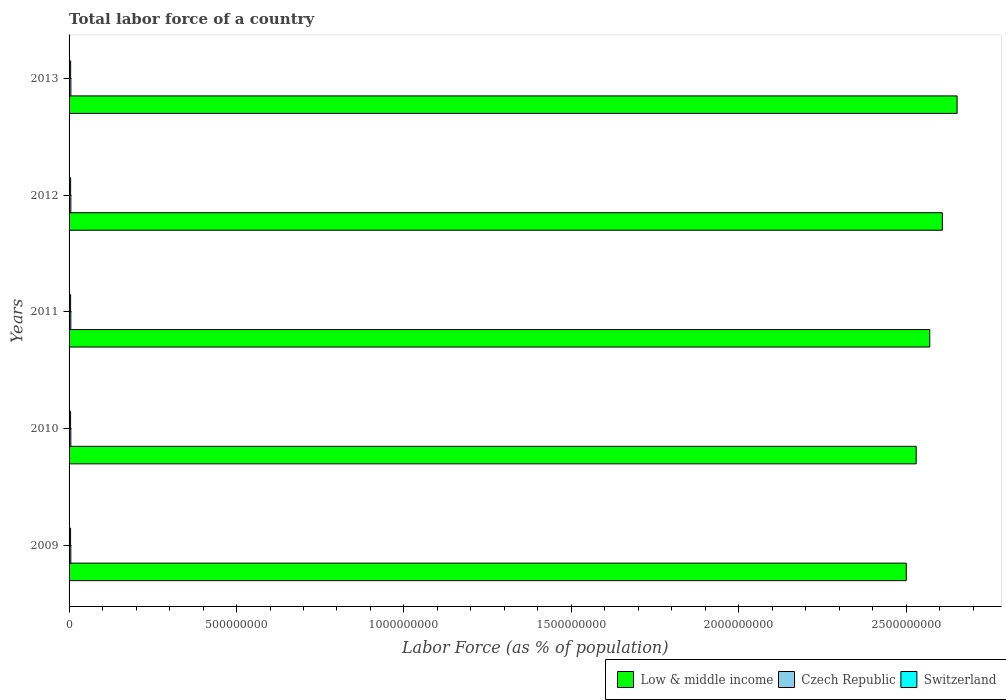How many different coloured bars are there?
Make the answer very short. 3. How many groups of bars are there?
Make the answer very short. 5. What is the label of the 5th group of bars from the top?
Provide a short and direct response. 2009. In how many cases, is the number of bars for a given year not equal to the number of legend labels?
Keep it short and to the point. 0. What is the percentage of labor force in Low & middle income in 2009?
Ensure brevity in your answer.  2.50e+09. Across all years, what is the maximum percentage of labor force in Switzerland?
Provide a succinct answer. 4.70e+06. Across all years, what is the minimum percentage of labor force in Low & middle income?
Offer a terse response. 2.50e+09. In which year was the percentage of labor force in Switzerland minimum?
Your answer should be compact. 2009. What is the total percentage of labor force in Czech Republic in the graph?
Give a very brief answer. 2.63e+07. What is the difference between the percentage of labor force in Czech Republic in 2010 and that in 2012?
Your answer should be compact. -4.67e+04. What is the difference between the percentage of labor force in Switzerland in 2010 and the percentage of labor force in Czech Republic in 2012?
Offer a terse response. -7.70e+05. What is the average percentage of labor force in Low & middle income per year?
Ensure brevity in your answer.  2.57e+09. In the year 2009, what is the difference between the percentage of labor force in Czech Republic and percentage of labor force in Switzerland?
Keep it short and to the point. 7.66e+05. What is the ratio of the percentage of labor force in Switzerland in 2011 to that in 2012?
Make the answer very short. 0.99. Is the difference between the percentage of labor force in Czech Republic in 2011 and 2013 greater than the difference between the percentage of labor force in Switzerland in 2011 and 2013?
Keep it short and to the point. Yes. What is the difference between the highest and the second highest percentage of labor force in Low & middle income?
Ensure brevity in your answer.  4.41e+07. What is the difference between the highest and the lowest percentage of labor force in Switzerland?
Offer a very short reply. 2.19e+05. What does the 2nd bar from the top in 2009 represents?
Provide a succinct answer. Czech Republic. What does the 3rd bar from the bottom in 2009 represents?
Provide a short and direct response. Switzerland. Is it the case that in every year, the sum of the percentage of labor force in Switzerland and percentage of labor force in Czech Republic is greater than the percentage of labor force in Low & middle income?
Offer a terse response. No. How many bars are there?
Offer a very short reply. 15. Are all the bars in the graph horizontal?
Offer a terse response. Yes. Does the graph contain any zero values?
Make the answer very short. No. Where does the legend appear in the graph?
Offer a very short reply. Bottom right. How many legend labels are there?
Make the answer very short. 3. What is the title of the graph?
Make the answer very short. Total labor force of a country. What is the label or title of the X-axis?
Your answer should be compact. Labor Force (as % of population). What is the Labor Force (as % of population) in Low & middle income in 2009?
Keep it short and to the point. 2.50e+09. What is the Labor Force (as % of population) in Czech Republic in 2009?
Keep it short and to the point. 5.25e+06. What is the Labor Force (as % of population) in Switzerland in 2009?
Offer a very short reply. 4.48e+06. What is the Labor Force (as % of population) of Low & middle income in 2010?
Your answer should be compact. 2.53e+09. What is the Labor Force (as % of population) in Czech Republic in 2010?
Offer a terse response. 5.24e+06. What is the Labor Force (as % of population) of Switzerland in 2010?
Your response must be concise. 4.51e+06. What is the Labor Force (as % of population) of Low & middle income in 2011?
Ensure brevity in your answer.  2.57e+09. What is the Labor Force (as % of population) in Czech Republic in 2011?
Make the answer very short. 5.24e+06. What is the Labor Force (as % of population) in Switzerland in 2011?
Your answer should be very brief. 4.58e+06. What is the Labor Force (as % of population) of Low & middle income in 2012?
Ensure brevity in your answer.  2.61e+09. What is the Labor Force (as % of population) of Czech Republic in 2012?
Offer a very short reply. 5.28e+06. What is the Labor Force (as % of population) of Switzerland in 2012?
Offer a terse response. 4.64e+06. What is the Labor Force (as % of population) in Low & middle income in 2013?
Give a very brief answer. 2.65e+09. What is the Labor Force (as % of population) in Czech Republic in 2013?
Offer a terse response. 5.34e+06. What is the Labor Force (as % of population) of Switzerland in 2013?
Offer a very short reply. 4.70e+06. Across all years, what is the maximum Labor Force (as % of population) in Low & middle income?
Offer a terse response. 2.65e+09. Across all years, what is the maximum Labor Force (as % of population) in Czech Republic?
Offer a terse response. 5.34e+06. Across all years, what is the maximum Labor Force (as % of population) in Switzerland?
Offer a very short reply. 4.70e+06. Across all years, what is the minimum Labor Force (as % of population) in Low & middle income?
Your answer should be very brief. 2.50e+09. Across all years, what is the minimum Labor Force (as % of population) in Czech Republic?
Keep it short and to the point. 5.24e+06. Across all years, what is the minimum Labor Force (as % of population) in Switzerland?
Your answer should be compact. 4.48e+06. What is the total Labor Force (as % of population) of Low & middle income in the graph?
Your answer should be very brief. 1.29e+1. What is the total Labor Force (as % of population) in Czech Republic in the graph?
Keep it short and to the point. 2.63e+07. What is the total Labor Force (as % of population) in Switzerland in the graph?
Your response must be concise. 2.29e+07. What is the difference between the Labor Force (as % of population) in Low & middle income in 2009 and that in 2010?
Keep it short and to the point. -2.96e+07. What is the difference between the Labor Force (as % of population) of Czech Republic in 2009 and that in 2010?
Give a very brief answer. 1.23e+04. What is the difference between the Labor Force (as % of population) in Switzerland in 2009 and that in 2010?
Your answer should be compact. -3.13e+04. What is the difference between the Labor Force (as % of population) of Low & middle income in 2009 and that in 2011?
Make the answer very short. -7.02e+07. What is the difference between the Labor Force (as % of population) of Czech Republic in 2009 and that in 2011?
Give a very brief answer. 9408. What is the difference between the Labor Force (as % of population) of Switzerland in 2009 and that in 2011?
Your answer should be compact. -1.00e+05. What is the difference between the Labor Force (as % of population) of Low & middle income in 2009 and that in 2012?
Your response must be concise. -1.08e+08. What is the difference between the Labor Force (as % of population) in Czech Republic in 2009 and that in 2012?
Offer a very short reply. -3.45e+04. What is the difference between the Labor Force (as % of population) in Switzerland in 2009 and that in 2012?
Offer a very short reply. -1.55e+05. What is the difference between the Labor Force (as % of population) in Low & middle income in 2009 and that in 2013?
Your answer should be very brief. -1.52e+08. What is the difference between the Labor Force (as % of population) of Czech Republic in 2009 and that in 2013?
Ensure brevity in your answer.  -8.96e+04. What is the difference between the Labor Force (as % of population) of Switzerland in 2009 and that in 2013?
Ensure brevity in your answer.  -2.19e+05. What is the difference between the Labor Force (as % of population) of Low & middle income in 2010 and that in 2011?
Your answer should be very brief. -4.06e+07. What is the difference between the Labor Force (as % of population) in Czech Republic in 2010 and that in 2011?
Make the answer very short. -2853. What is the difference between the Labor Force (as % of population) in Switzerland in 2010 and that in 2011?
Keep it short and to the point. -6.91e+04. What is the difference between the Labor Force (as % of population) in Low & middle income in 2010 and that in 2012?
Make the answer very short. -7.80e+07. What is the difference between the Labor Force (as % of population) in Czech Republic in 2010 and that in 2012?
Your answer should be compact. -4.67e+04. What is the difference between the Labor Force (as % of population) in Switzerland in 2010 and that in 2012?
Give a very brief answer. -1.23e+05. What is the difference between the Labor Force (as % of population) in Low & middle income in 2010 and that in 2013?
Keep it short and to the point. -1.22e+08. What is the difference between the Labor Force (as % of population) of Czech Republic in 2010 and that in 2013?
Your response must be concise. -1.02e+05. What is the difference between the Labor Force (as % of population) in Switzerland in 2010 and that in 2013?
Give a very brief answer. -1.88e+05. What is the difference between the Labor Force (as % of population) of Low & middle income in 2011 and that in 2012?
Your answer should be compact. -3.75e+07. What is the difference between the Labor Force (as % of population) in Czech Republic in 2011 and that in 2012?
Give a very brief answer. -4.39e+04. What is the difference between the Labor Force (as % of population) of Switzerland in 2011 and that in 2012?
Your response must be concise. -5.41e+04. What is the difference between the Labor Force (as % of population) of Low & middle income in 2011 and that in 2013?
Your response must be concise. -8.16e+07. What is the difference between the Labor Force (as % of population) of Czech Republic in 2011 and that in 2013?
Offer a very short reply. -9.90e+04. What is the difference between the Labor Force (as % of population) in Switzerland in 2011 and that in 2013?
Offer a terse response. -1.19e+05. What is the difference between the Labor Force (as % of population) of Low & middle income in 2012 and that in 2013?
Your answer should be very brief. -4.41e+07. What is the difference between the Labor Force (as % of population) of Czech Republic in 2012 and that in 2013?
Make the answer very short. -5.51e+04. What is the difference between the Labor Force (as % of population) of Switzerland in 2012 and that in 2013?
Provide a short and direct response. -6.44e+04. What is the difference between the Labor Force (as % of population) of Low & middle income in 2009 and the Labor Force (as % of population) of Czech Republic in 2010?
Keep it short and to the point. 2.49e+09. What is the difference between the Labor Force (as % of population) of Low & middle income in 2009 and the Labor Force (as % of population) of Switzerland in 2010?
Offer a very short reply. 2.50e+09. What is the difference between the Labor Force (as % of population) of Czech Republic in 2009 and the Labor Force (as % of population) of Switzerland in 2010?
Your answer should be compact. 7.35e+05. What is the difference between the Labor Force (as % of population) in Low & middle income in 2009 and the Labor Force (as % of population) in Czech Republic in 2011?
Offer a terse response. 2.49e+09. What is the difference between the Labor Force (as % of population) of Low & middle income in 2009 and the Labor Force (as % of population) of Switzerland in 2011?
Provide a short and direct response. 2.50e+09. What is the difference between the Labor Force (as % of population) of Czech Republic in 2009 and the Labor Force (as % of population) of Switzerland in 2011?
Your response must be concise. 6.66e+05. What is the difference between the Labor Force (as % of population) of Low & middle income in 2009 and the Labor Force (as % of population) of Czech Republic in 2012?
Offer a terse response. 2.49e+09. What is the difference between the Labor Force (as % of population) of Low & middle income in 2009 and the Labor Force (as % of population) of Switzerland in 2012?
Offer a terse response. 2.50e+09. What is the difference between the Labor Force (as % of population) in Czech Republic in 2009 and the Labor Force (as % of population) in Switzerland in 2012?
Your answer should be very brief. 6.12e+05. What is the difference between the Labor Force (as % of population) of Low & middle income in 2009 and the Labor Force (as % of population) of Czech Republic in 2013?
Ensure brevity in your answer.  2.49e+09. What is the difference between the Labor Force (as % of population) in Low & middle income in 2009 and the Labor Force (as % of population) in Switzerland in 2013?
Provide a short and direct response. 2.50e+09. What is the difference between the Labor Force (as % of population) of Czech Republic in 2009 and the Labor Force (as % of population) of Switzerland in 2013?
Ensure brevity in your answer.  5.47e+05. What is the difference between the Labor Force (as % of population) of Low & middle income in 2010 and the Labor Force (as % of population) of Czech Republic in 2011?
Offer a very short reply. 2.52e+09. What is the difference between the Labor Force (as % of population) of Low & middle income in 2010 and the Labor Force (as % of population) of Switzerland in 2011?
Make the answer very short. 2.53e+09. What is the difference between the Labor Force (as % of population) in Czech Republic in 2010 and the Labor Force (as % of population) in Switzerland in 2011?
Offer a terse response. 6.54e+05. What is the difference between the Labor Force (as % of population) of Low & middle income in 2010 and the Labor Force (as % of population) of Czech Republic in 2012?
Keep it short and to the point. 2.52e+09. What is the difference between the Labor Force (as % of population) of Low & middle income in 2010 and the Labor Force (as % of population) of Switzerland in 2012?
Give a very brief answer. 2.52e+09. What is the difference between the Labor Force (as % of population) of Czech Republic in 2010 and the Labor Force (as % of population) of Switzerland in 2012?
Keep it short and to the point. 6.00e+05. What is the difference between the Labor Force (as % of population) of Low & middle income in 2010 and the Labor Force (as % of population) of Czech Republic in 2013?
Offer a very short reply. 2.52e+09. What is the difference between the Labor Force (as % of population) of Low & middle income in 2010 and the Labor Force (as % of population) of Switzerland in 2013?
Give a very brief answer. 2.52e+09. What is the difference between the Labor Force (as % of population) in Czech Republic in 2010 and the Labor Force (as % of population) in Switzerland in 2013?
Offer a very short reply. 5.35e+05. What is the difference between the Labor Force (as % of population) of Low & middle income in 2011 and the Labor Force (as % of population) of Czech Republic in 2012?
Provide a short and direct response. 2.56e+09. What is the difference between the Labor Force (as % of population) in Low & middle income in 2011 and the Labor Force (as % of population) in Switzerland in 2012?
Your answer should be very brief. 2.57e+09. What is the difference between the Labor Force (as % of population) of Czech Republic in 2011 and the Labor Force (as % of population) of Switzerland in 2012?
Your answer should be compact. 6.02e+05. What is the difference between the Labor Force (as % of population) of Low & middle income in 2011 and the Labor Force (as % of population) of Czech Republic in 2013?
Give a very brief answer. 2.56e+09. What is the difference between the Labor Force (as % of population) of Low & middle income in 2011 and the Labor Force (as % of population) of Switzerland in 2013?
Ensure brevity in your answer.  2.57e+09. What is the difference between the Labor Force (as % of population) in Czech Republic in 2011 and the Labor Force (as % of population) in Switzerland in 2013?
Give a very brief answer. 5.38e+05. What is the difference between the Labor Force (as % of population) in Low & middle income in 2012 and the Labor Force (as % of population) in Czech Republic in 2013?
Your answer should be compact. 2.60e+09. What is the difference between the Labor Force (as % of population) in Low & middle income in 2012 and the Labor Force (as % of population) in Switzerland in 2013?
Your answer should be compact. 2.60e+09. What is the difference between the Labor Force (as % of population) of Czech Republic in 2012 and the Labor Force (as % of population) of Switzerland in 2013?
Provide a short and direct response. 5.82e+05. What is the average Labor Force (as % of population) of Low & middle income per year?
Make the answer very short. 2.57e+09. What is the average Labor Force (as % of population) in Czech Republic per year?
Offer a terse response. 5.27e+06. What is the average Labor Force (as % of population) of Switzerland per year?
Your answer should be compact. 4.58e+06. In the year 2009, what is the difference between the Labor Force (as % of population) in Low & middle income and Labor Force (as % of population) in Czech Republic?
Give a very brief answer. 2.49e+09. In the year 2009, what is the difference between the Labor Force (as % of population) in Low & middle income and Labor Force (as % of population) in Switzerland?
Make the answer very short. 2.50e+09. In the year 2009, what is the difference between the Labor Force (as % of population) in Czech Republic and Labor Force (as % of population) in Switzerland?
Your answer should be very brief. 7.66e+05. In the year 2010, what is the difference between the Labor Force (as % of population) in Low & middle income and Labor Force (as % of population) in Czech Republic?
Make the answer very short. 2.52e+09. In the year 2010, what is the difference between the Labor Force (as % of population) of Low & middle income and Labor Force (as % of population) of Switzerland?
Your answer should be compact. 2.53e+09. In the year 2010, what is the difference between the Labor Force (as % of population) of Czech Republic and Labor Force (as % of population) of Switzerland?
Keep it short and to the point. 7.23e+05. In the year 2011, what is the difference between the Labor Force (as % of population) of Low & middle income and Labor Force (as % of population) of Czech Republic?
Ensure brevity in your answer.  2.56e+09. In the year 2011, what is the difference between the Labor Force (as % of population) in Low & middle income and Labor Force (as % of population) in Switzerland?
Your response must be concise. 2.57e+09. In the year 2011, what is the difference between the Labor Force (as % of population) of Czech Republic and Labor Force (as % of population) of Switzerland?
Your answer should be compact. 6.57e+05. In the year 2012, what is the difference between the Labor Force (as % of population) in Low & middle income and Labor Force (as % of population) in Czech Republic?
Ensure brevity in your answer.  2.60e+09. In the year 2012, what is the difference between the Labor Force (as % of population) of Low & middle income and Labor Force (as % of population) of Switzerland?
Make the answer very short. 2.60e+09. In the year 2012, what is the difference between the Labor Force (as % of population) of Czech Republic and Labor Force (as % of population) of Switzerland?
Your response must be concise. 6.46e+05. In the year 2013, what is the difference between the Labor Force (as % of population) of Low & middle income and Labor Force (as % of population) of Czech Republic?
Give a very brief answer. 2.65e+09. In the year 2013, what is the difference between the Labor Force (as % of population) in Low & middle income and Labor Force (as % of population) in Switzerland?
Your answer should be compact. 2.65e+09. In the year 2013, what is the difference between the Labor Force (as % of population) of Czech Republic and Labor Force (as % of population) of Switzerland?
Provide a succinct answer. 6.37e+05. What is the ratio of the Labor Force (as % of population) in Low & middle income in 2009 to that in 2010?
Your answer should be compact. 0.99. What is the ratio of the Labor Force (as % of population) of Switzerland in 2009 to that in 2010?
Make the answer very short. 0.99. What is the ratio of the Labor Force (as % of population) in Low & middle income in 2009 to that in 2011?
Make the answer very short. 0.97. What is the ratio of the Labor Force (as % of population) of Czech Republic in 2009 to that in 2011?
Make the answer very short. 1. What is the ratio of the Labor Force (as % of population) in Switzerland in 2009 to that in 2011?
Give a very brief answer. 0.98. What is the ratio of the Labor Force (as % of population) in Low & middle income in 2009 to that in 2012?
Provide a short and direct response. 0.96. What is the ratio of the Labor Force (as % of population) in Czech Republic in 2009 to that in 2012?
Offer a very short reply. 0.99. What is the ratio of the Labor Force (as % of population) of Switzerland in 2009 to that in 2012?
Your response must be concise. 0.97. What is the ratio of the Labor Force (as % of population) in Low & middle income in 2009 to that in 2013?
Give a very brief answer. 0.94. What is the ratio of the Labor Force (as % of population) of Czech Republic in 2009 to that in 2013?
Provide a succinct answer. 0.98. What is the ratio of the Labor Force (as % of population) of Switzerland in 2009 to that in 2013?
Ensure brevity in your answer.  0.95. What is the ratio of the Labor Force (as % of population) in Low & middle income in 2010 to that in 2011?
Your answer should be very brief. 0.98. What is the ratio of the Labor Force (as % of population) of Czech Republic in 2010 to that in 2011?
Keep it short and to the point. 1. What is the ratio of the Labor Force (as % of population) in Switzerland in 2010 to that in 2011?
Offer a very short reply. 0.98. What is the ratio of the Labor Force (as % of population) of Low & middle income in 2010 to that in 2012?
Provide a succinct answer. 0.97. What is the ratio of the Labor Force (as % of population) of Switzerland in 2010 to that in 2012?
Ensure brevity in your answer.  0.97. What is the ratio of the Labor Force (as % of population) in Low & middle income in 2010 to that in 2013?
Make the answer very short. 0.95. What is the ratio of the Labor Force (as % of population) of Czech Republic in 2010 to that in 2013?
Your response must be concise. 0.98. What is the ratio of the Labor Force (as % of population) of Switzerland in 2010 to that in 2013?
Make the answer very short. 0.96. What is the ratio of the Labor Force (as % of population) in Low & middle income in 2011 to that in 2012?
Ensure brevity in your answer.  0.99. What is the ratio of the Labor Force (as % of population) in Czech Republic in 2011 to that in 2012?
Provide a short and direct response. 0.99. What is the ratio of the Labor Force (as % of population) of Switzerland in 2011 to that in 2012?
Offer a terse response. 0.99. What is the ratio of the Labor Force (as % of population) in Low & middle income in 2011 to that in 2013?
Provide a short and direct response. 0.97. What is the ratio of the Labor Force (as % of population) in Czech Republic in 2011 to that in 2013?
Your answer should be very brief. 0.98. What is the ratio of the Labor Force (as % of population) of Switzerland in 2011 to that in 2013?
Ensure brevity in your answer.  0.97. What is the ratio of the Labor Force (as % of population) in Low & middle income in 2012 to that in 2013?
Offer a terse response. 0.98. What is the ratio of the Labor Force (as % of population) in Czech Republic in 2012 to that in 2013?
Keep it short and to the point. 0.99. What is the ratio of the Labor Force (as % of population) in Switzerland in 2012 to that in 2013?
Keep it short and to the point. 0.99. What is the difference between the highest and the second highest Labor Force (as % of population) in Low & middle income?
Offer a very short reply. 4.41e+07. What is the difference between the highest and the second highest Labor Force (as % of population) of Czech Republic?
Offer a very short reply. 5.51e+04. What is the difference between the highest and the second highest Labor Force (as % of population) of Switzerland?
Your answer should be very brief. 6.44e+04. What is the difference between the highest and the lowest Labor Force (as % of population) in Low & middle income?
Provide a succinct answer. 1.52e+08. What is the difference between the highest and the lowest Labor Force (as % of population) in Czech Republic?
Provide a short and direct response. 1.02e+05. What is the difference between the highest and the lowest Labor Force (as % of population) in Switzerland?
Offer a very short reply. 2.19e+05. 